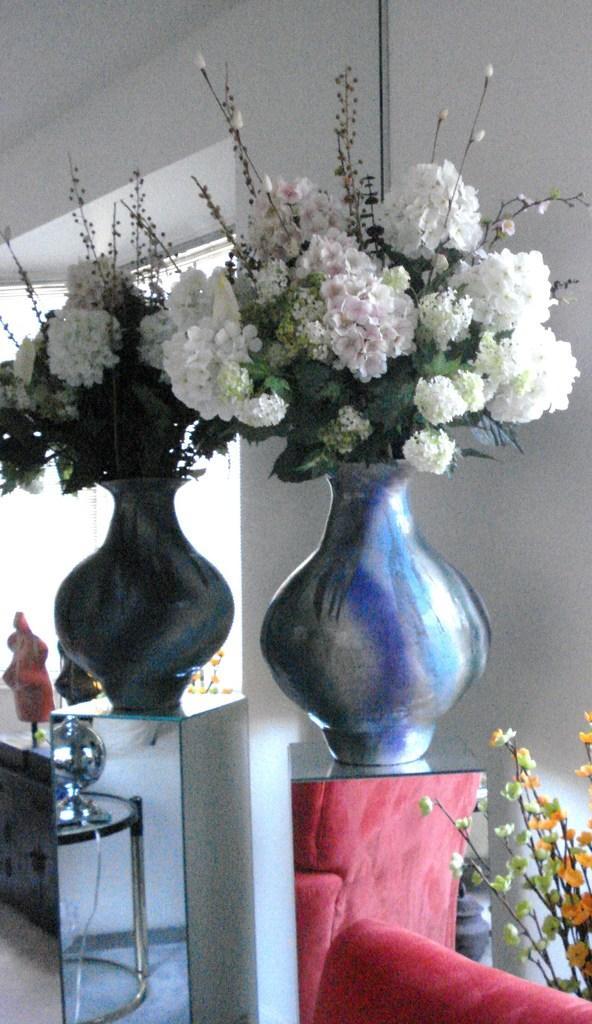In one or two sentences, can you explain what this image depicts? In the center of the image there is a flower vase with white color flowers in it. At the bottom of the image there is a red color chair. To the left side of the image there is a mirror. In the background of the image there is a wall. 